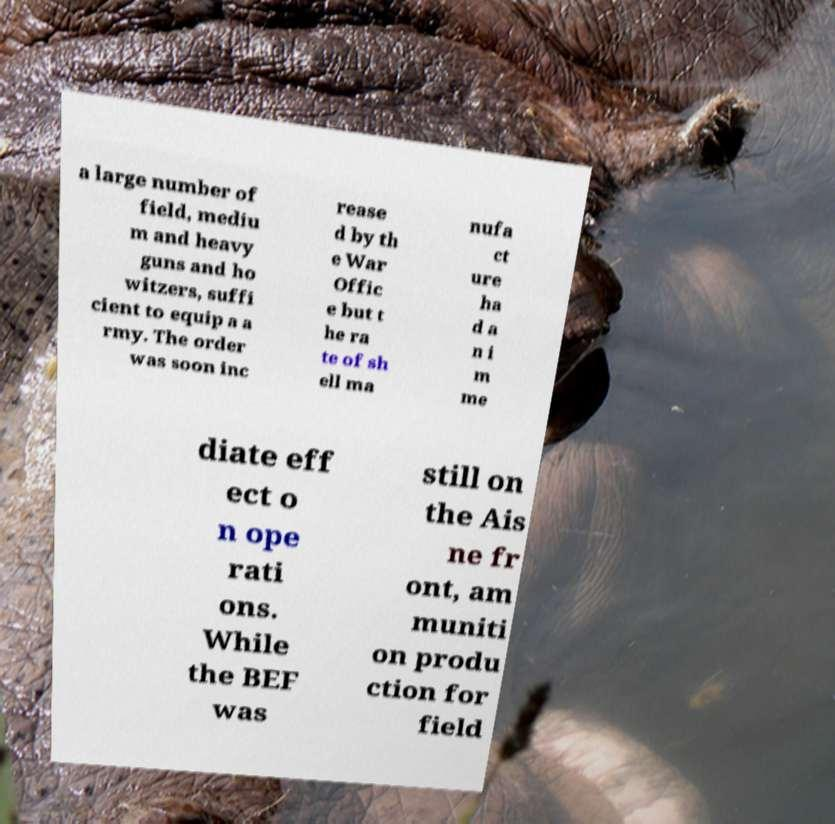Could you assist in decoding the text presented in this image and type it out clearly? a large number of field, mediu m and heavy guns and ho witzers, suffi cient to equip a a rmy. The order was soon inc rease d by th e War Offic e but t he ra te of sh ell ma nufa ct ure ha d a n i m me diate eff ect o n ope rati ons. While the BEF was still on the Ais ne fr ont, am muniti on produ ction for field 